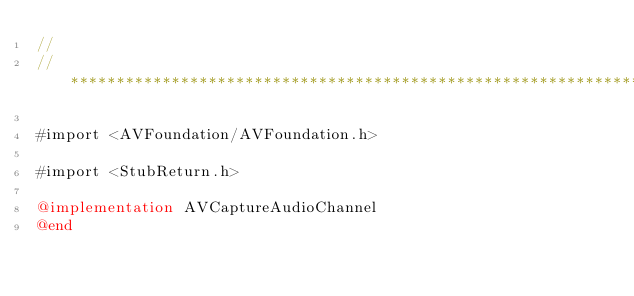<code> <loc_0><loc_0><loc_500><loc_500><_ObjectiveC_>//
//******************************************************************************

#import <AVFoundation/AVFoundation.h>

#import <StubReturn.h>

@implementation AVCaptureAudioChannel
@end
</code> 